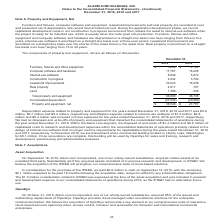According to Alarmcom Holdings's financial document, What was the depreciation expense related to property and equipment for the years ended December 31, 2019? According to the financial document, $5.9 million (in millions). The relevant text states: "e years ended December 31, 2019, 2018 and 2017 was $5.9 million, $5.7 million and $5.4 million, respectively. Amortization expense related to internal-use software..." Also, How much did the company purchase land a commercial building located in Liberty Lake, Washington for in December 2019? According to the financial document, $5.1 million (in millions). The relevant text states: "l building located in Liberty Lake, Washington for $5.1 million. Once renovations are complete, this building will be used by OpenEye for sales and training, resea..." Also, What was the amount of Furniture, fixtures and office equipment in 2019? According to the financial document, $5,604 (in thousands). The relevant text states: "9 2018 Furniture, fixtures and office equipment $ 5,604 $ 4,102 Computer software and hardware 17,767 16,228 Internal-use software 8,949 5,072 Construction..." Also, How many net components of property and equipment in 2019 exceeded $20,000 thousand? Based on the analysis, there are 1 instances. The counting process: Leasehold improvements. Also, can you calculate: What was the change in leasehold improvements between 2018 and 2019? Based on the calculation: 23,223-18,338, the result is 4885 (in thousands). This is based on the information: "on in progress 4,232 3,790 Leasehold improvements 23,223 18,338 Real property 4,917 707 Land 1,398 508 Total property and equipment 66,090 48,745 Accumulate rogress 4,232 3,790 Leasehold improvements ..." The key data points involved are: 18,338, 23,223. Also, can you calculate: What was the percentage change in the total property and equipment between 2018 and 2019? To answer this question, I need to perform calculations using the financial data. The calculation is: (66,090-48,745)/48,745, which equals 35.58 (percentage). This is based on the information: "and 1,398 508 Total property and equipment 66,090 48,745 Accumulated depreciation (27,542) (20,988) Property and equipment, net $ 38,548 $ 27,757 7 707 Land 1,398 508 Total property and equipment 66,0..." The key data points involved are: 48,745, 66,090. 